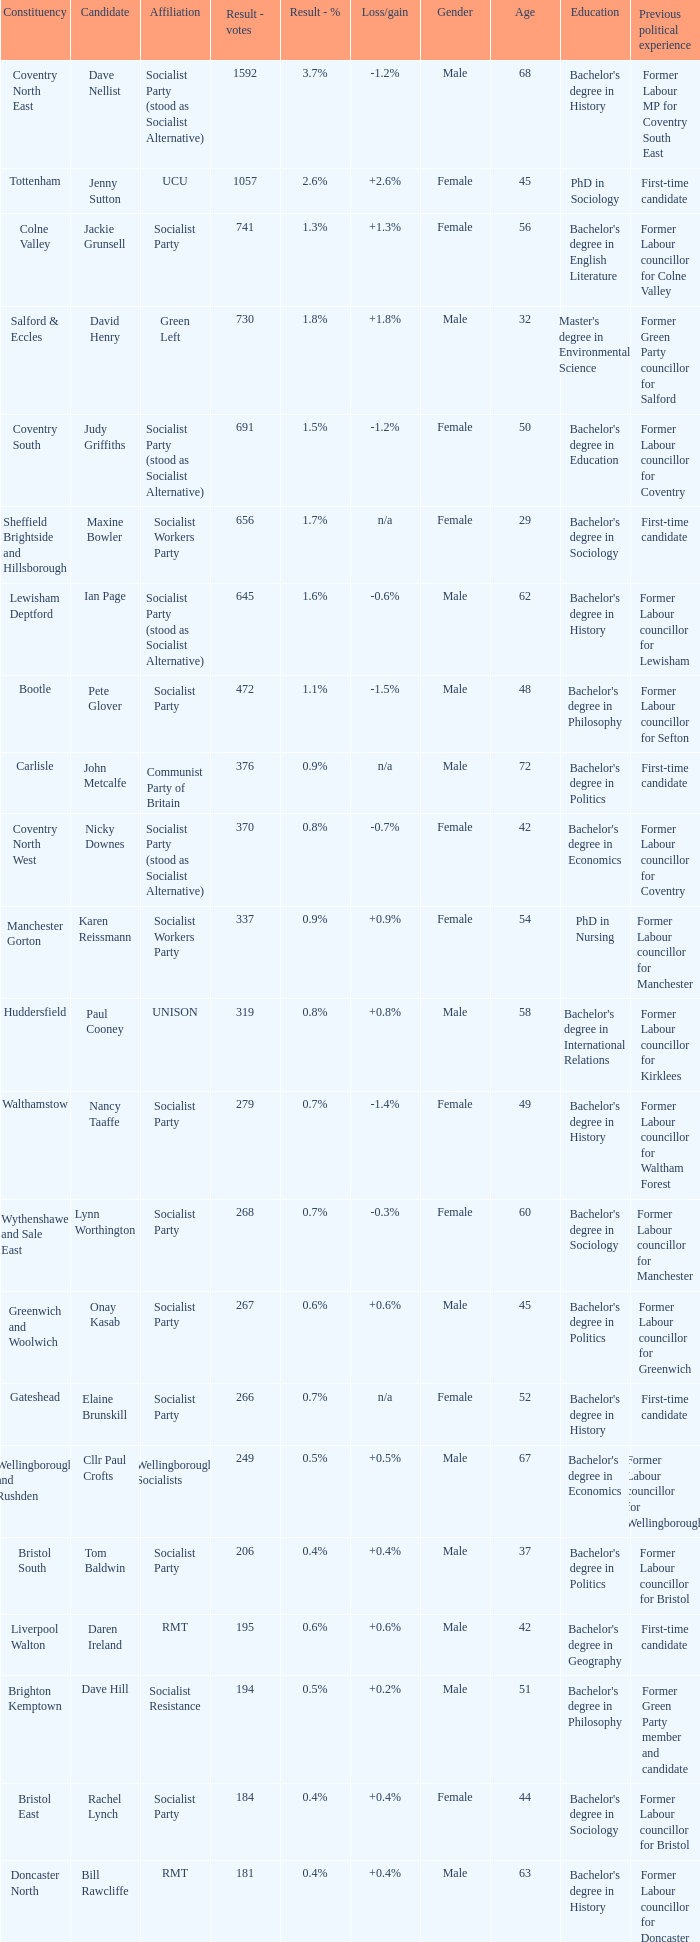What is every candidate for the Cardiff Central constituency? Ross Saunders. Help me parse the entirety of this table. {'header': ['Constituency', 'Candidate', 'Affiliation', 'Result - votes', 'Result - %', 'Loss/gain', 'Gender', 'Age', 'Education', 'Previous political experience'], 'rows': [['Coventry North East', 'Dave Nellist', 'Socialist Party (stood as Socialist Alternative)', '1592', '3.7%', '-1.2%', 'Male', '68', "Bachelor's degree in History", 'Former Labour MP for Coventry South East'], ['Tottenham', 'Jenny Sutton', 'UCU', '1057', '2.6%', '+2.6%', 'Female', '45', 'PhD in Sociology', 'First-time candidate'], ['Colne Valley', 'Jackie Grunsell', 'Socialist Party', '741', '1.3%', '+1.3%', 'Female', '56', "Bachelor's degree in English Literature", 'Former Labour councillor for Colne Valley'], ['Salford & Eccles', 'David Henry', 'Green Left', '730', '1.8%', '+1.8%', 'Male', '32', "Master's degree in Environmental Science", 'Former Green Party councillor for Salford'], ['Coventry South', 'Judy Griffiths', 'Socialist Party (stood as Socialist Alternative)', '691', '1.5%', '-1.2%', 'Female', '50', "Bachelor's degree in Education", 'Former Labour councillor for Coventry'], ['Sheffield Brightside and Hillsborough', 'Maxine Bowler', 'Socialist Workers Party', '656', '1.7%', 'n/a', 'Female', '29', "Bachelor's degree in Sociology", 'First-time candidate'], ['Lewisham Deptford', 'Ian Page', 'Socialist Party (stood as Socialist Alternative)', '645', '1.6%', '-0.6%', 'Male', '62', "Bachelor's degree in History", 'Former Labour councillor for Lewisham'], ['Bootle', 'Pete Glover', 'Socialist Party', '472', '1.1%', '-1.5%', 'Male', '48', "Bachelor's degree in Philosophy", 'Former Labour councillor for Sefton'], ['Carlisle', 'John Metcalfe', 'Communist Party of Britain', '376', '0.9%', 'n/a', 'Male', '72', "Bachelor's degree in Politics", 'First-time candidate'], ['Coventry North West', 'Nicky Downes', 'Socialist Party (stood as Socialist Alternative)', '370', '0.8%', '-0.7%', 'Female', '42', "Bachelor's degree in Economics", 'Former Labour councillor for Coventry'], ['Manchester Gorton', 'Karen Reissmann', 'Socialist Workers Party', '337', '0.9%', '+0.9%', 'Female', '54', 'PhD in Nursing', 'Former Labour councillor for Manchester'], ['Huddersfield', 'Paul Cooney', 'UNISON', '319', '0.8%', '+0.8%', 'Male', '58', "Bachelor's degree in International Relations", 'Former Labour councillor for Kirklees'], ['Walthamstow', 'Nancy Taaffe', 'Socialist Party', '279', '0.7%', '-1.4%', 'Female', '49', "Bachelor's degree in History", 'Former Labour councillor for Waltham Forest'], ['Wythenshawe and Sale East', 'Lynn Worthington', 'Socialist Party', '268', '0.7%', '-0.3%', 'Female', '60', "Bachelor's degree in Sociology", 'Former Labour councillor for Manchester'], ['Greenwich and Woolwich', 'Onay Kasab', 'Socialist Party', '267', '0.6%', '+0.6%', 'Male', '45', "Bachelor's degree in Politics", 'Former Labour councillor for Greenwich'], ['Gateshead', 'Elaine Brunskill', 'Socialist Party', '266', '0.7%', 'n/a', 'Female', '52', "Bachelor's degree in History", 'First-time candidate'], ['Wellingborough and Rushden', 'Cllr Paul Crofts', 'Wellingborough Socialists', '249', '0.5%', '+0.5%', 'Male', '67', "Bachelor's degree in Economics", 'Former Labour councillor for Wellingborough'], ['Bristol South', 'Tom Baldwin', 'Socialist Party', '206', '0.4%', '+0.4%', 'Male', '37', "Bachelor's degree in Politics", 'Former Labour councillor for Bristol'], ['Liverpool Walton', 'Daren Ireland', 'RMT', '195', '0.6%', '+0.6%', 'Male', '42', "Bachelor's degree in Geography", 'First-time candidate'], ['Brighton Kemptown', 'Dave Hill', 'Socialist Resistance', '194', '0.5%', '+0.2%', 'Male', '51', "Bachelor's degree in Philosophy", 'Former Green Party member and candidate'], ['Bristol East', 'Rachel Lynch', 'Socialist Party', '184', '0.4%', '+0.4%', 'Female', '44', "Bachelor's degree in Sociology", 'Former Labour councillor for Bristol'], ['Doncaster North', 'Bill Rawcliffe', 'RMT', '181', '0.4%', '+0.4%', 'Male', '63', "Bachelor's degree in History", 'Former Labour councillor for Doncaster'], ['Swansea West', 'Rob Williams', 'Socialist Party', '179', '0.5%', '-0.4%', 'Male', '56', "Bachelor's degree in History", 'Former Labour councillor for Swansea'], ['Spelthorne', 'Paul Couchman', 'Socialist Party', '176', '0.4%', '+0.4%', 'Male', '39', "Bachelor's degree in Politics", 'First-time candidate'], ['Southampton Itchen', 'Tim Cutter', 'Socialist Party', '168', '0.4%', '+0.4%', 'Male', '35', "Bachelor's degree in Sociology", 'First-time candidate'], ['Cardiff Central', 'Ross Saunders', 'Socialist Party', '162', '0.4%', '+0.4%', 'Male', '28', "Bachelor's degree in Politics", 'Former Labour councillor for Cardiff'], ['Leicester West', 'Steve Score', 'Socialist Party', '157', '0.4%', '-1.3%', 'Male', '60', "Bachelor's degree in Economics", 'Former Labour councillor for Leicester'], ['Portsmouth North', 'Mick Tosh', 'RMT', '154', '0.3%', '+0.3%', 'Male', '49', "Bachelor's degree in Geography", 'First-time candidate'], ['Kingston upon Hull West and Hessle', 'Keith Gibson', 'Socialist Party', '150', '0.5%', '+0.5%', 'Male', '54', "Bachelor's degree in Sociology", 'Former Labour councillor for Hull'], ['Stoke-on-Trent Central', 'Matthew Wright', 'Socialist Party', '133', '0.4%', '-0.5%', 'Male', '43', "Bachelor's degree in Politics", 'Former Labour councillor for Stoke-on-Trent']]} 